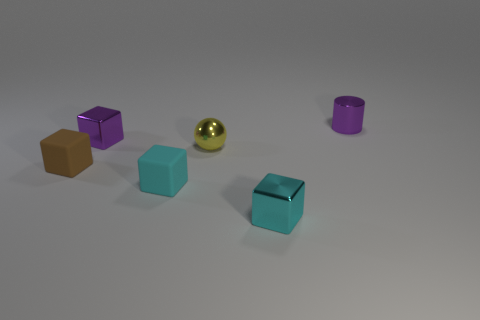Subtract all small purple shiny blocks. How many blocks are left? 3 Subtract all purple balls. How many cyan cubes are left? 2 Subtract 2 cubes. How many cubes are left? 2 Add 1 purple shiny things. How many objects exist? 7 Subtract all brown cubes. How many cubes are left? 3 Subtract all balls. How many objects are left? 5 Subtract all blue cubes. Subtract all blue spheres. How many cubes are left? 4 Add 5 yellow shiny objects. How many yellow shiny objects are left? 6 Add 4 cyan rubber cubes. How many cyan rubber cubes exist? 5 Subtract 0 blue cubes. How many objects are left? 6 